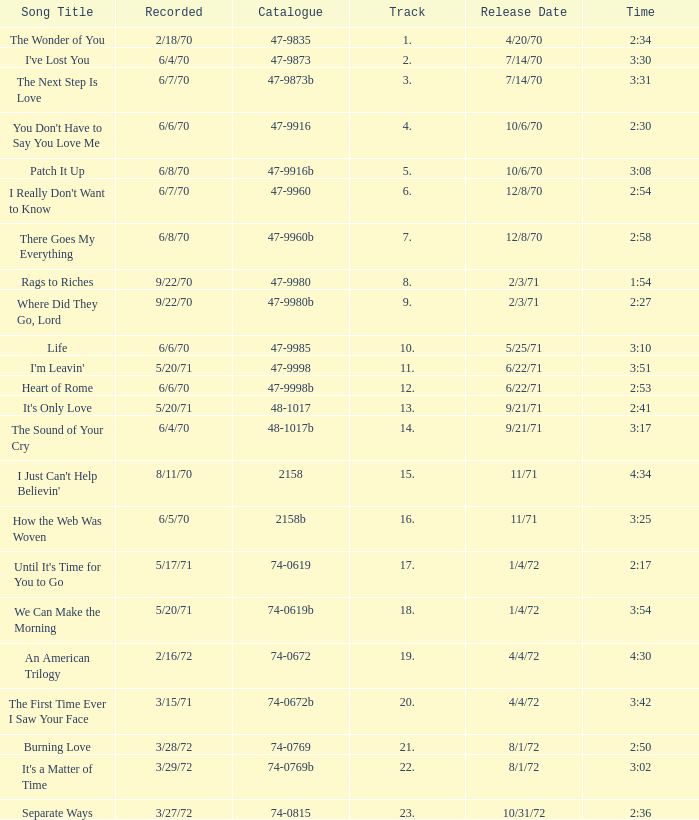Which song was released 12/8/70 with a time of 2:54? I Really Don't Want to Know. Could you parse the entire table as a dict? {'header': ['Song Title', 'Recorded', 'Catalogue', 'Track', 'Release Date', 'Time'], 'rows': [['The Wonder of You', '2/18/70', '47-9835', '1.', '4/20/70', '2:34'], ["I've Lost You", '6/4/70', '47-9873', '2.', '7/14/70', '3:30'], ['The Next Step Is Love', '6/7/70', '47-9873b', '3.', '7/14/70', '3:31'], ["You Don't Have to Say You Love Me", '6/6/70', '47-9916', '4.', '10/6/70', '2:30'], ['Patch It Up', '6/8/70', '47-9916b', '5.', '10/6/70', '3:08'], ["I Really Don't Want to Know", '6/7/70', '47-9960', '6.', '12/8/70', '2:54'], ['There Goes My Everything', '6/8/70', '47-9960b', '7.', '12/8/70', '2:58'], ['Rags to Riches', '9/22/70', '47-9980', '8.', '2/3/71', '1:54'], ['Where Did They Go, Lord', '9/22/70', '47-9980b', '9.', '2/3/71', '2:27'], ['Life', '6/6/70', '47-9985', '10.', '5/25/71', '3:10'], ["I'm Leavin'", '5/20/71', '47-9998', '11.', '6/22/71', '3:51'], ['Heart of Rome', '6/6/70', '47-9998b', '12.', '6/22/71', '2:53'], ["It's Only Love", '5/20/71', '48-1017', '13.', '9/21/71', '2:41'], ['The Sound of Your Cry', '6/4/70', '48-1017b', '14.', '9/21/71', '3:17'], ["I Just Can't Help Believin'", '8/11/70', '2158', '15.', '11/71', '4:34'], ['How the Web Was Woven', '6/5/70', '2158b', '16.', '11/71', '3:25'], ["Until It's Time for You to Go", '5/17/71', '74-0619', '17.', '1/4/72', '2:17'], ['We Can Make the Morning', '5/20/71', '74-0619b', '18.', '1/4/72', '3:54'], ['An American Trilogy', '2/16/72', '74-0672', '19.', '4/4/72', '4:30'], ['The First Time Ever I Saw Your Face', '3/15/71', '74-0672b', '20.', '4/4/72', '3:42'], ['Burning Love', '3/28/72', '74-0769', '21.', '8/1/72', '2:50'], ["It's a Matter of Time", '3/29/72', '74-0769b', '22.', '8/1/72', '3:02'], ['Separate Ways', '3/27/72', '74-0815', '23.', '10/31/72', '2:36']]} 